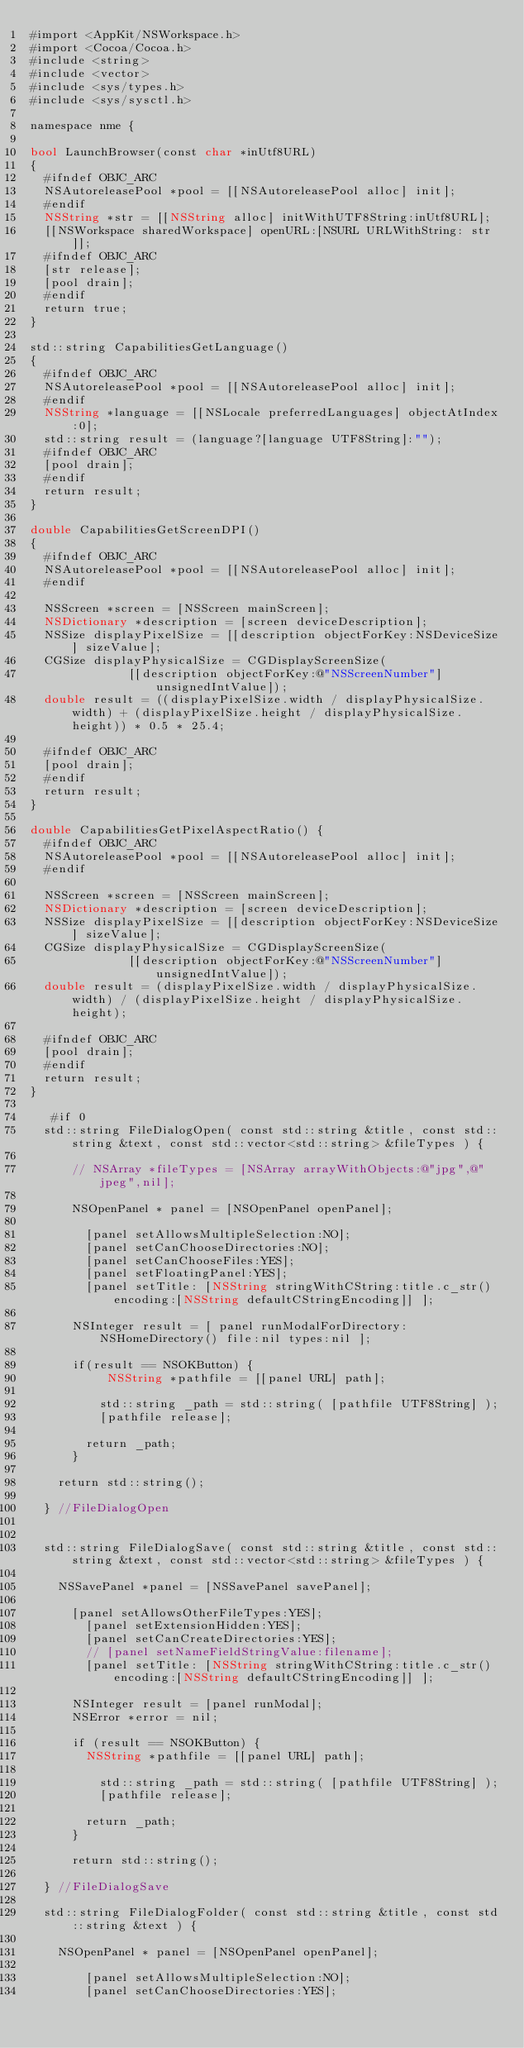<code> <loc_0><loc_0><loc_500><loc_500><_ObjectiveC_>#import <AppKit/NSWorkspace.h>
#import <Cocoa/Cocoa.h>
#include <string>
#include <vector>
#include <sys/types.h>
#include <sys/sysctl.h>

namespace nme {

bool LaunchBrowser(const char *inUtf8URL)
{
	#ifndef OBJC_ARC
	NSAutoreleasePool *pool = [[NSAutoreleasePool alloc] init];
	#endif
	NSString *str = [[NSString alloc] initWithUTF8String:inUtf8URL];
	[[NSWorkspace sharedWorkspace] openURL:[NSURL URLWithString: str]];
	#ifndef OBJC_ARC
	[str release];
	[pool drain];
	#endif
	return true;
}

std::string CapabilitiesGetLanguage()
{
	#ifndef OBJC_ARC
	NSAutoreleasePool *pool = [[NSAutoreleasePool alloc] init];
	#endif
	NSString *language = [[NSLocale preferredLanguages] objectAtIndex:0];
	std::string result = (language?[language UTF8String]:"");
	#ifndef OBJC_ARC
	[pool drain];
	#endif
	return result;
}

double CapabilitiesGetScreenDPI()
{
	#ifndef OBJC_ARC
	NSAutoreleasePool *pool = [[NSAutoreleasePool alloc] init];
	#endif
	
	NSScreen *screen = [NSScreen mainScreen];
	NSDictionary *description = [screen deviceDescription];
	NSSize displayPixelSize = [[description objectForKey:NSDeviceSize] sizeValue];
	CGSize displayPhysicalSize = CGDisplayScreenSize(
	            [[description objectForKey:@"NSScreenNumber"] unsignedIntValue]);
	double result = ((displayPixelSize.width / displayPhysicalSize.width) + (displayPixelSize.height / displayPhysicalSize.height)) * 0.5 * 25.4;
	
	#ifndef OBJC_ARC
	[pool drain];
	#endif
	return result;
}

double CapabilitiesGetPixelAspectRatio() {
	#ifndef OBJC_ARC
	NSAutoreleasePool *pool = [[NSAutoreleasePool alloc] init];
	#endif
	
	NSScreen *screen = [NSScreen mainScreen];
	NSDictionary *description = [screen deviceDescription];
	NSSize displayPixelSize = [[description objectForKey:NSDeviceSize] sizeValue];
	CGSize displayPhysicalSize = CGDisplayScreenSize(
	            [[description objectForKey:@"NSScreenNumber"] unsignedIntValue]);
	double result = (displayPixelSize.width / displayPhysicalSize.width) / (displayPixelSize.height / displayPhysicalSize.height);
	
	#ifndef OBJC_ARC
	[pool drain];
	#endif
	return result;
}

   #if 0
	std::string FileDialogOpen( const std::string &title, const std::string &text, const std::vector<std::string> &fileTypes ) {
	    
	    // NSArray *fileTypes = [NSArray arrayWithObjects:@"jpg",@"jpeg",nil];
	    
	    NSOpenPanel * panel = [NSOpenPanel openPanel];

		    [panel setAllowsMultipleSelection:NO];
		    [panel setCanChooseDirectories:NO];
		    [panel setCanChooseFiles:YES];
		    [panel setFloatingPanel:YES];
		    [panel setTitle: [NSString stringWithCString:title.c_str() encoding:[NSString defaultCStringEncoding]] ]; 

	    NSInteger result = [ panel runModalForDirectory:NSHomeDirectory() file:nil types:nil ];

	    if(result == NSOKButton) {
	         NSString *pathfile = [[panel URL] path];

	    		std::string _path = std::string( [pathfile UTF8String] );
	    		[pathfile release];
	    		
	    	return _path;
	    }

		return std::string();

	} //FileDialogOpen
	

	std::string FileDialogSave( const std::string &title, const std::string &text, const std::vector<std::string> &fileTypes ) {

		NSSavePanel *panel = [NSSavePanel savePanel];

			[panel setAllowsOtherFileTypes:YES];
		    [panel setExtensionHidden:YES];
		    [panel setCanCreateDirectories:YES];
		    // [panel setNameFieldStringValue:filename];
		    [panel setTitle: [NSString stringWithCString:title.c_str() encoding:[NSString defaultCStringEncoding]] ]; 

	    NSInteger result = [panel runModal];
	    NSError *error = nil;

	    if (result == NSOKButton) {
	    	NSString *pathfile = [[panel URL] path];

	    		std::string _path = std::string( [pathfile UTF8String] );
	    		[pathfile release];

	    	return _path;
	    }

	    return std::string();

	} //FileDialogSave
	
	std::string FileDialogFolder( const std::string &title, const std::string &text ) {

		NSOpenPanel * panel = [NSOpenPanel openPanel];

		    [panel setAllowsMultipleSelection:NO];
		    [panel setCanChooseDirectories:YES];</code> 